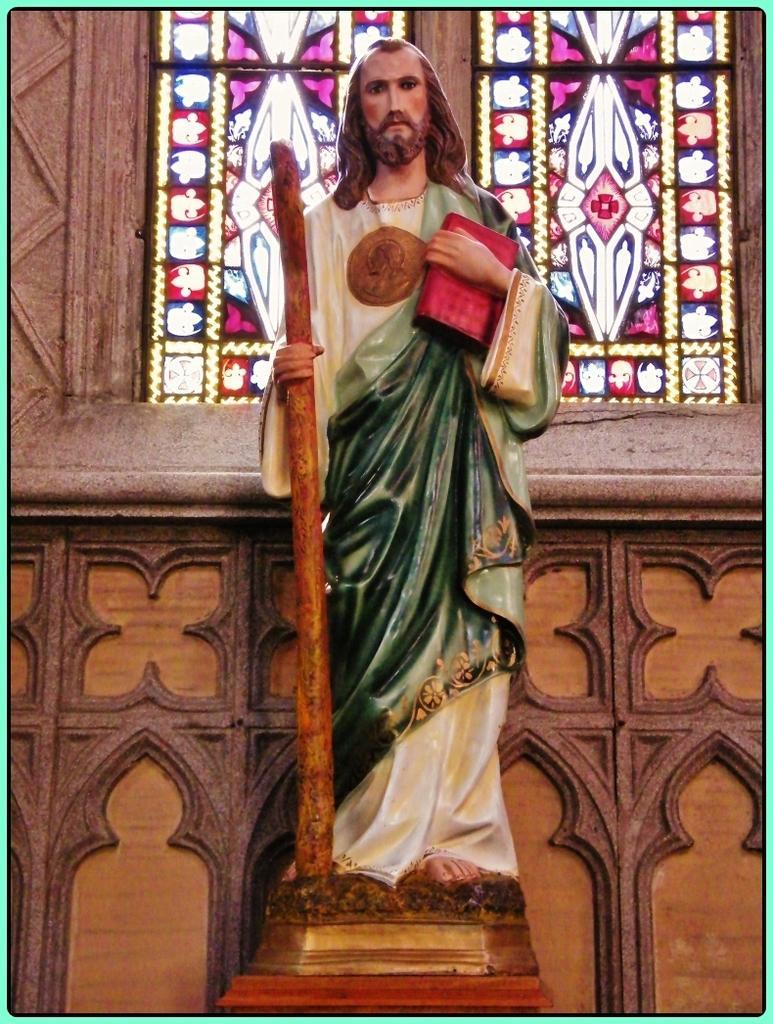Could you give a brief overview of what you see in this image? In the picture I can see Jesus statue holding a stick and a book in his hands. In the background, I can see the the stained windows to the wall and we can see the design wall. 